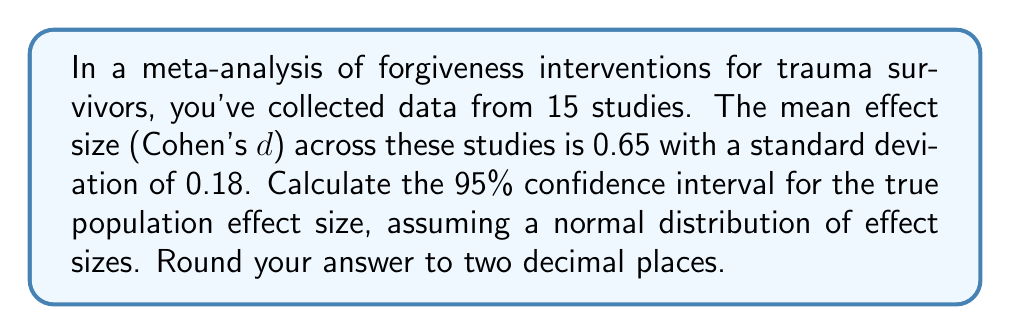Solve this math problem. To calculate the 95% confidence interval for the true population effect size, we'll use the formula:

$$ CI = \bar{d} \pm (t_{critical} \times SE_{\bar{d}}) $$

Where:
- $\bar{d}$ is the mean effect size
- $t_{critical}$ is the critical t-value for a 95% confidence level with n-1 degrees of freedom
- $SE_{\bar{d}}$ is the standard error of the mean effect size

Steps:

1. We have $\bar{d} = 0.65$ and $n = 15$ studies.

2. Calculate the standard error of the mean effect size:
   $SE_{\bar{d}} = \frac{s}{\sqrt{n}} = \frac{0.18}{\sqrt{15}} = 0.0465$

3. Find the critical t-value:
   For a 95% confidence level and 14 degrees of freedom (n-1), $t_{critical} = 2.145$ (from t-distribution table)

4. Calculate the margin of error:
   $Margin of Error = t_{critical} \times SE_{\bar{d}} = 2.145 \times 0.0465 = 0.0997$

5. Calculate the confidence interval:
   $Lower bound = 0.65 - 0.0997 = 0.5503$
   $Upper bound = 0.65 + 0.0997 = 0.7497$

6. Round to two decimal places:
   $Lower bound = 0.55$
   $Upper bound = 0.75$
Answer: The 95% confidence interval for the true population effect size is (0.55, 0.75). 